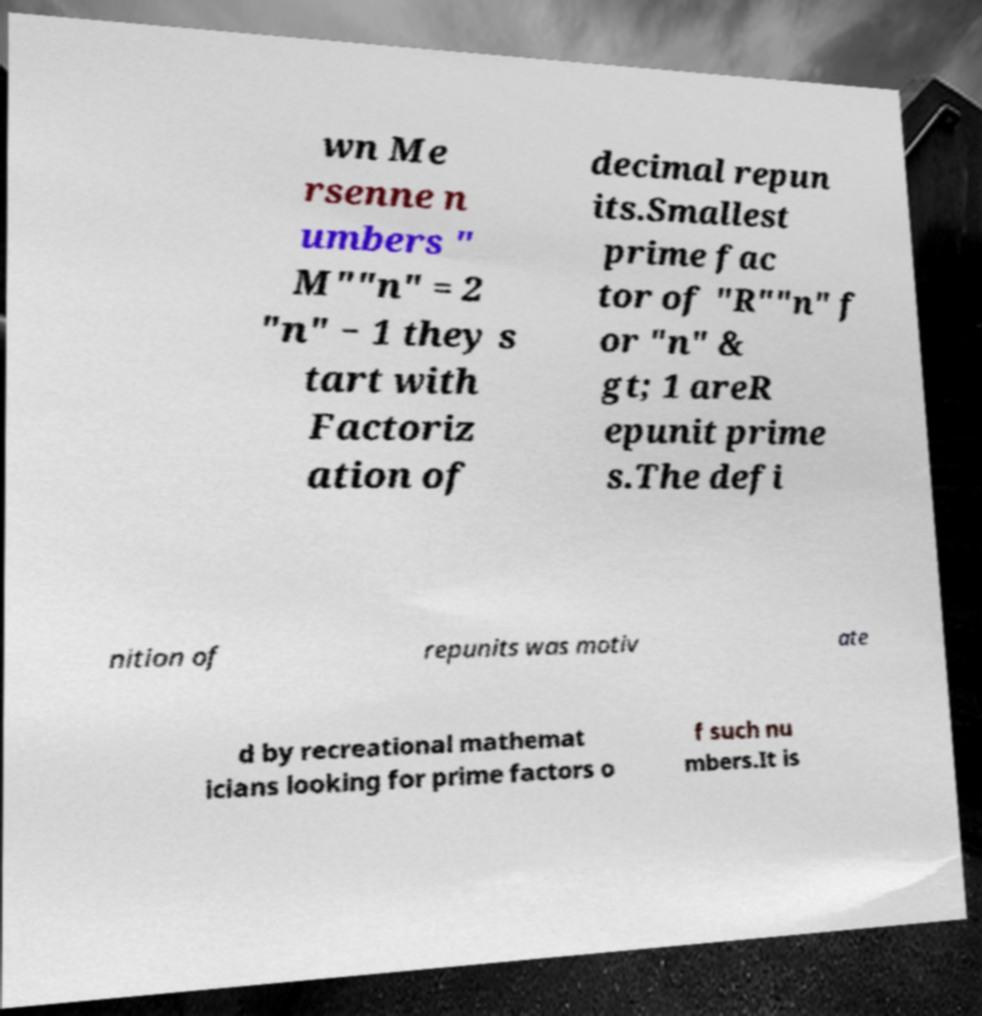For documentation purposes, I need the text within this image transcribed. Could you provide that? wn Me rsenne n umbers " M""n" = 2 "n" − 1 they s tart with Factoriz ation of decimal repun its.Smallest prime fac tor of "R""n" f or "n" & gt; 1 areR epunit prime s.The defi nition of repunits was motiv ate d by recreational mathemat icians looking for prime factors o f such nu mbers.It is 